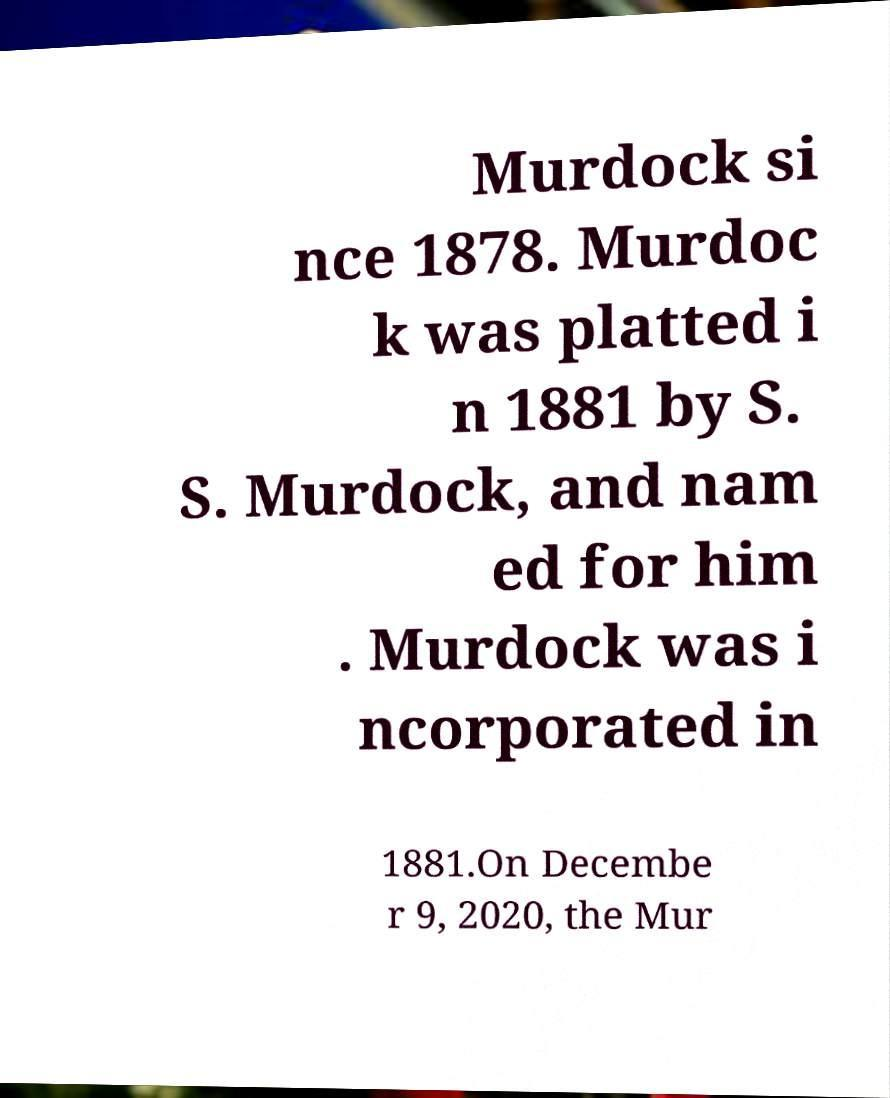What messages or text are displayed in this image? I need them in a readable, typed format. Murdock si nce 1878. Murdoc k was platted i n 1881 by S. S. Murdock, and nam ed for him . Murdock was i ncorporated in 1881.On Decembe r 9, 2020, the Mur 